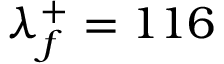Convert formula to latex. <formula><loc_0><loc_0><loc_500><loc_500>\lambda _ { f } ^ { + } = 1 1 6</formula> 